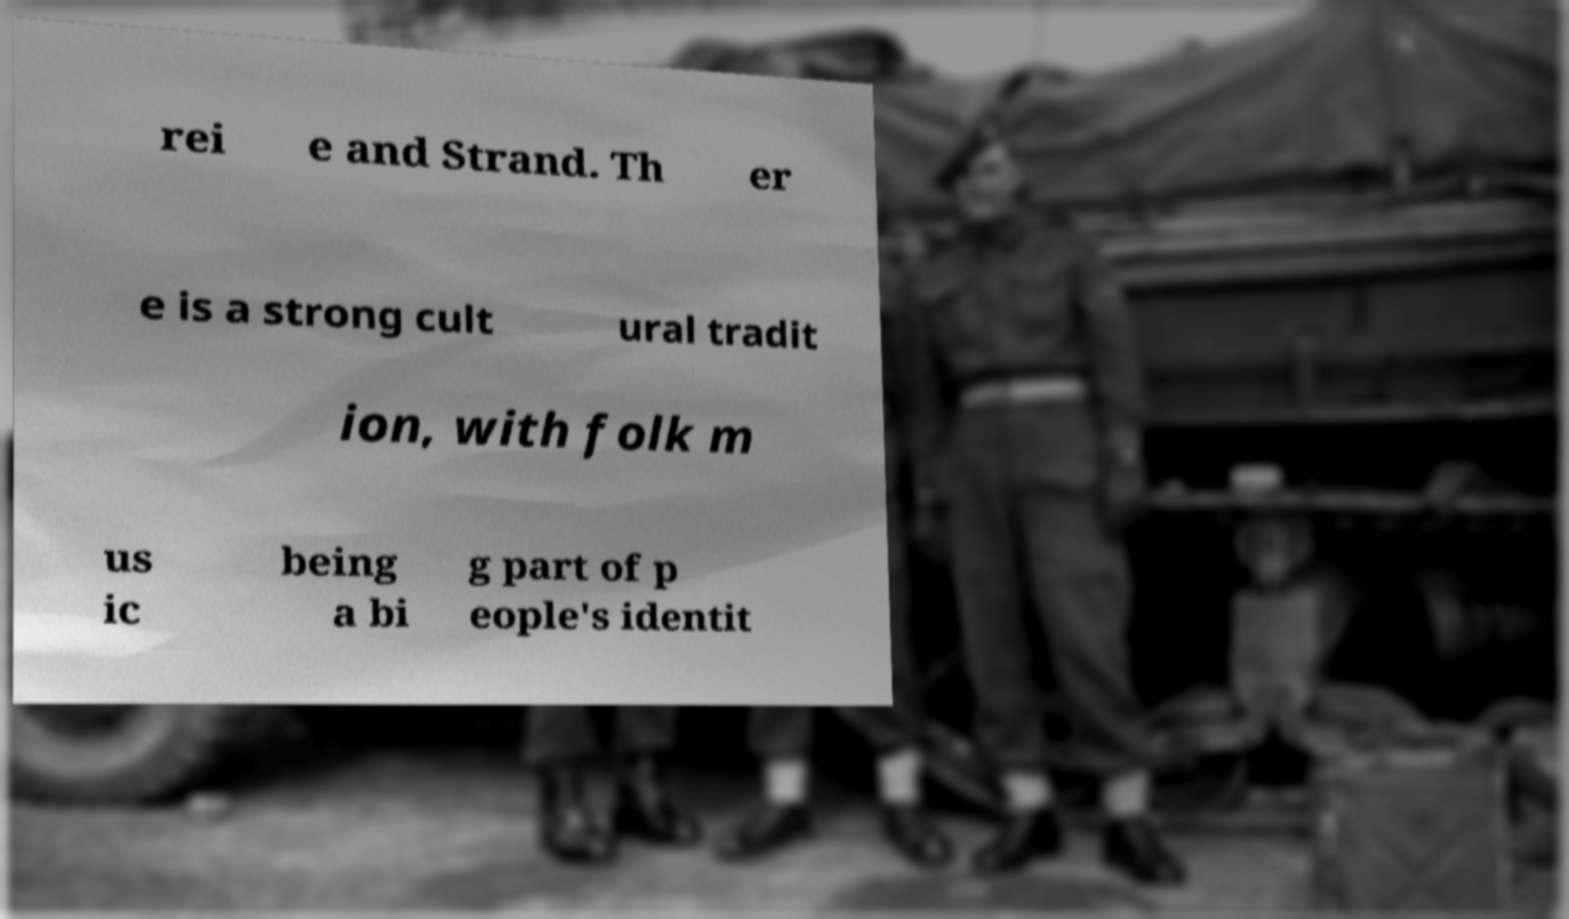Can you accurately transcribe the text from the provided image for me? rei e and Strand. Th er e is a strong cult ural tradit ion, with folk m us ic being a bi g part of p eople's identit 